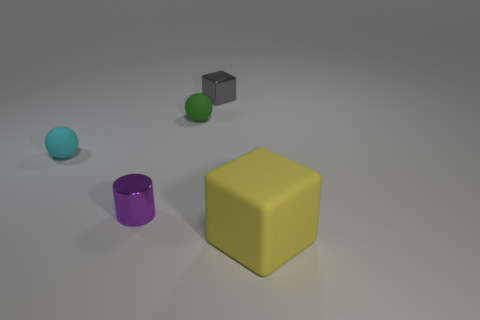Subtract 1 cubes. How many cubes are left? 1 Add 1 green cylinders. How many objects exist? 6 Subtract 0 red cylinders. How many objects are left? 5 Subtract all spheres. How many objects are left? 3 Subtract all green cubes. Subtract all blue cylinders. How many cubes are left? 2 Subtract all cyan spheres. How many gray cubes are left? 1 Subtract all big objects. Subtract all blue balls. How many objects are left? 4 Add 2 tiny purple things. How many tiny purple things are left? 3 Add 1 small cylinders. How many small cylinders exist? 2 